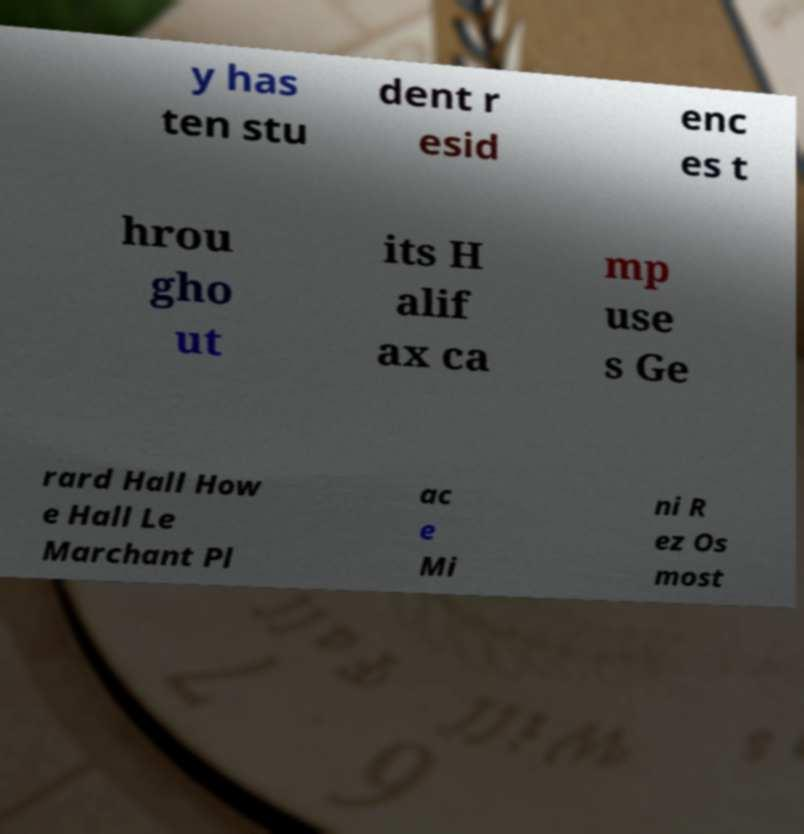Can you accurately transcribe the text from the provided image for me? y has ten stu dent r esid enc es t hrou gho ut its H alif ax ca mp use s Ge rard Hall How e Hall Le Marchant Pl ac e Mi ni R ez Os most 